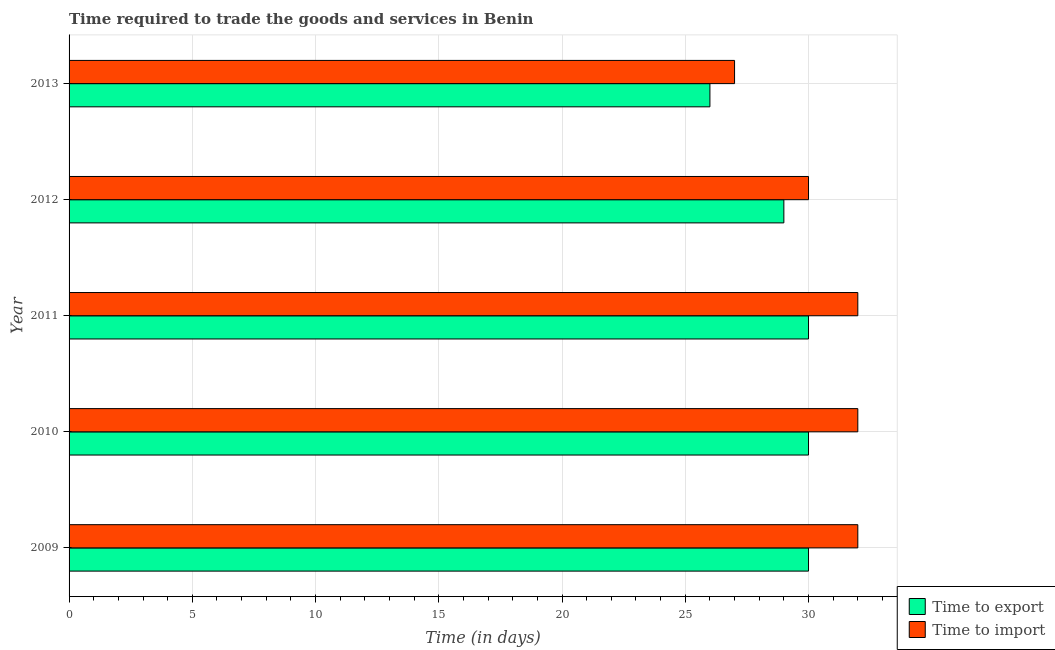How many different coloured bars are there?
Give a very brief answer. 2. Are the number of bars on each tick of the Y-axis equal?
Make the answer very short. Yes. What is the label of the 3rd group of bars from the top?
Offer a terse response. 2011. In how many cases, is the number of bars for a given year not equal to the number of legend labels?
Keep it short and to the point. 0. What is the time to export in 2012?
Provide a short and direct response. 29. Across all years, what is the maximum time to import?
Offer a terse response. 32. Across all years, what is the minimum time to import?
Ensure brevity in your answer.  27. In which year was the time to import maximum?
Offer a terse response. 2009. In which year was the time to import minimum?
Provide a short and direct response. 2013. What is the total time to export in the graph?
Provide a short and direct response. 145. What is the difference between the time to export in 2011 and that in 2013?
Make the answer very short. 4. What is the difference between the time to export in 2013 and the time to import in 2011?
Your answer should be compact. -6. In the year 2012, what is the difference between the time to export and time to import?
Offer a very short reply. -1. What is the ratio of the time to import in 2009 to that in 2012?
Offer a very short reply. 1.07. What is the difference between the highest and the second highest time to export?
Offer a terse response. 0. What is the difference between the highest and the lowest time to import?
Make the answer very short. 5. In how many years, is the time to import greater than the average time to import taken over all years?
Provide a short and direct response. 3. Is the sum of the time to import in 2009 and 2011 greater than the maximum time to export across all years?
Ensure brevity in your answer.  Yes. What does the 2nd bar from the top in 2012 represents?
Make the answer very short. Time to export. What does the 1st bar from the bottom in 2009 represents?
Your answer should be compact. Time to export. How many bars are there?
Give a very brief answer. 10. How many years are there in the graph?
Your answer should be very brief. 5. What is the difference between two consecutive major ticks on the X-axis?
Provide a short and direct response. 5. Does the graph contain grids?
Ensure brevity in your answer.  Yes. Where does the legend appear in the graph?
Ensure brevity in your answer.  Bottom right. How many legend labels are there?
Provide a succinct answer. 2. What is the title of the graph?
Make the answer very short. Time required to trade the goods and services in Benin. Does "GDP at market prices" appear as one of the legend labels in the graph?
Ensure brevity in your answer.  No. What is the label or title of the X-axis?
Provide a short and direct response. Time (in days). What is the Time (in days) in Time to export in 2010?
Provide a succinct answer. 30. What is the Time (in days) in Time to import in 2010?
Make the answer very short. 32. What is the Time (in days) in Time to export in 2011?
Provide a short and direct response. 30. What is the Time (in days) of Time to import in 2011?
Provide a succinct answer. 32. What is the Time (in days) in Time to import in 2012?
Your answer should be very brief. 30. What is the Time (in days) in Time to export in 2013?
Provide a short and direct response. 26. Across all years, what is the maximum Time (in days) in Time to import?
Offer a terse response. 32. Across all years, what is the minimum Time (in days) in Time to import?
Your answer should be compact. 27. What is the total Time (in days) in Time to export in the graph?
Give a very brief answer. 145. What is the total Time (in days) in Time to import in the graph?
Ensure brevity in your answer.  153. What is the difference between the Time (in days) in Time to export in 2009 and that in 2010?
Offer a terse response. 0. What is the difference between the Time (in days) of Time to export in 2009 and that in 2011?
Provide a succinct answer. 0. What is the difference between the Time (in days) of Time to import in 2009 and that in 2012?
Make the answer very short. 2. What is the difference between the Time (in days) of Time to export in 2009 and that in 2013?
Offer a very short reply. 4. What is the difference between the Time (in days) of Time to import in 2009 and that in 2013?
Your answer should be very brief. 5. What is the difference between the Time (in days) in Time to export in 2010 and that in 2011?
Offer a terse response. 0. What is the difference between the Time (in days) of Time to import in 2010 and that in 2011?
Ensure brevity in your answer.  0. What is the difference between the Time (in days) of Time to export in 2010 and that in 2013?
Your answer should be very brief. 4. What is the difference between the Time (in days) of Time to import in 2010 and that in 2013?
Offer a very short reply. 5. What is the difference between the Time (in days) of Time to export in 2011 and that in 2012?
Your answer should be compact. 1. What is the difference between the Time (in days) of Time to import in 2011 and that in 2012?
Make the answer very short. 2. What is the difference between the Time (in days) of Time to export in 2011 and that in 2013?
Your answer should be very brief. 4. What is the difference between the Time (in days) of Time to export in 2012 and that in 2013?
Provide a succinct answer. 3. What is the difference between the Time (in days) in Time to export in 2009 and the Time (in days) in Time to import in 2011?
Your answer should be very brief. -2. What is the difference between the Time (in days) of Time to export in 2010 and the Time (in days) of Time to import in 2013?
Ensure brevity in your answer.  3. What is the difference between the Time (in days) in Time to export in 2011 and the Time (in days) in Time to import in 2013?
Offer a terse response. 3. What is the difference between the Time (in days) in Time to export in 2012 and the Time (in days) in Time to import in 2013?
Your answer should be very brief. 2. What is the average Time (in days) of Time to export per year?
Ensure brevity in your answer.  29. What is the average Time (in days) of Time to import per year?
Provide a succinct answer. 30.6. In the year 2009, what is the difference between the Time (in days) of Time to export and Time (in days) of Time to import?
Offer a very short reply. -2. In the year 2010, what is the difference between the Time (in days) of Time to export and Time (in days) of Time to import?
Your answer should be compact. -2. In the year 2011, what is the difference between the Time (in days) in Time to export and Time (in days) in Time to import?
Give a very brief answer. -2. In the year 2012, what is the difference between the Time (in days) in Time to export and Time (in days) in Time to import?
Offer a terse response. -1. What is the ratio of the Time (in days) in Time to export in 2009 to that in 2012?
Offer a very short reply. 1.03. What is the ratio of the Time (in days) of Time to import in 2009 to that in 2012?
Your answer should be very brief. 1.07. What is the ratio of the Time (in days) in Time to export in 2009 to that in 2013?
Make the answer very short. 1.15. What is the ratio of the Time (in days) in Time to import in 2009 to that in 2013?
Ensure brevity in your answer.  1.19. What is the ratio of the Time (in days) in Time to export in 2010 to that in 2012?
Keep it short and to the point. 1.03. What is the ratio of the Time (in days) of Time to import in 2010 to that in 2012?
Your response must be concise. 1.07. What is the ratio of the Time (in days) in Time to export in 2010 to that in 2013?
Provide a succinct answer. 1.15. What is the ratio of the Time (in days) of Time to import in 2010 to that in 2013?
Offer a terse response. 1.19. What is the ratio of the Time (in days) of Time to export in 2011 to that in 2012?
Keep it short and to the point. 1.03. What is the ratio of the Time (in days) in Time to import in 2011 to that in 2012?
Make the answer very short. 1.07. What is the ratio of the Time (in days) of Time to export in 2011 to that in 2013?
Your answer should be compact. 1.15. What is the ratio of the Time (in days) in Time to import in 2011 to that in 2013?
Make the answer very short. 1.19. What is the ratio of the Time (in days) in Time to export in 2012 to that in 2013?
Give a very brief answer. 1.12. What is the difference between the highest and the second highest Time (in days) in Time to export?
Offer a terse response. 0. What is the difference between the highest and the second highest Time (in days) in Time to import?
Provide a succinct answer. 0. What is the difference between the highest and the lowest Time (in days) in Time to import?
Keep it short and to the point. 5. 